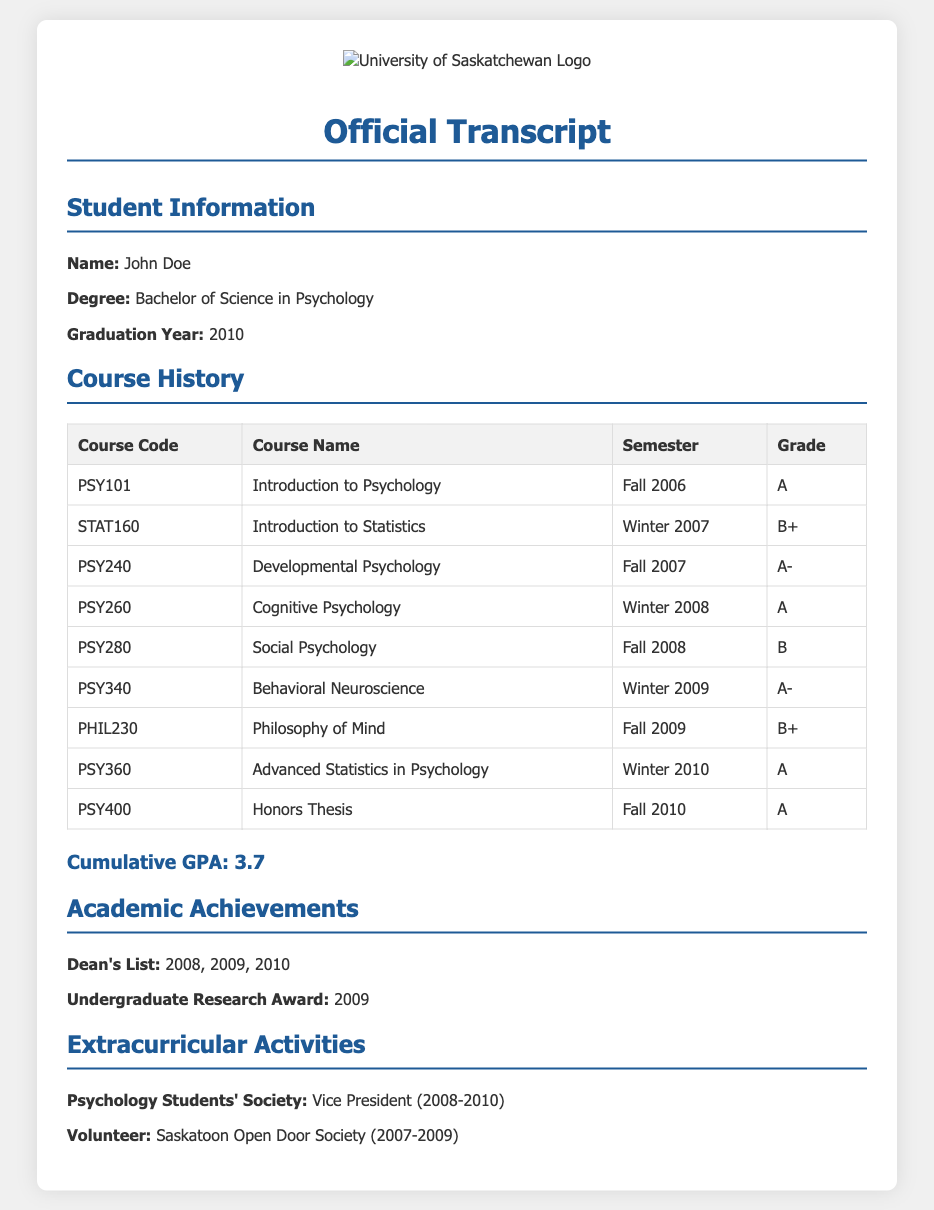What is the name of the student? The document provides the student's name in the Student Information section, which is John Doe.
Answer: John Doe What was the graduation year? The graduation year can be found in the Student Information section, which states 2010.
Answer: 2010 What was the cumulative GPA? The cumulative GPA is listed in the document and is indicated as 3.7.
Answer: 3.7 Which course did the student take in Fall 2006? The course taken in Fall 2006 is listed in the Course History section, which states Introduction to Psychology.
Answer: Introduction to Psychology How many courses were completed in total? The total number of courses is found in the Course History table, which lists 9 courses.
Answer: 9 Which extracurricular activity did the student hold a leadership position in? The document states the student was Vice President of the Psychology Students' Society from 2008 to 2010.
Answer: Vice President What achievement did the student receive in 2009? The Academic Achievements section mentions the Undergraduate Research Award received in 2009.
Answer: Undergraduate Research Award In which semester was the Honors Thesis completed? The Honors Thesis is listed in the Course History under the Fall 2010 semester.
Answer: Fall 2010 What grade did the student receive in Cognitive Psychology? The Course History indicates that the student received an A in Cognitive Psychology.
Answer: A 